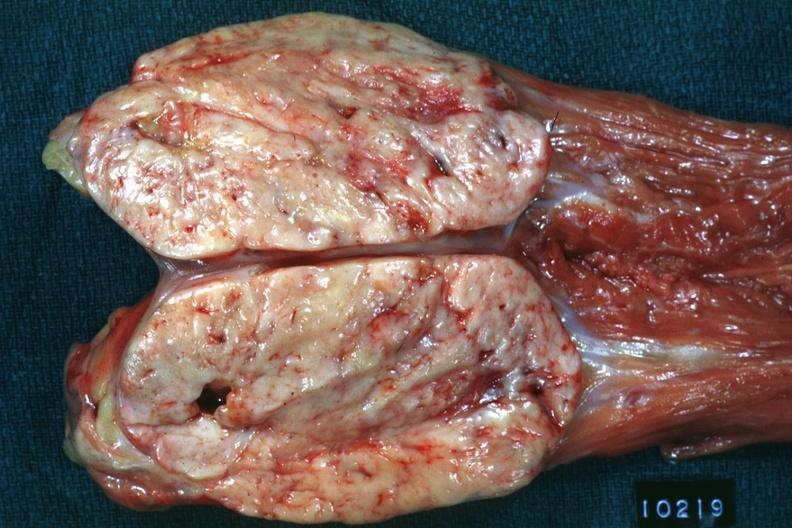s retroperitoneal leiomyosarcoma present?
Answer the question using a single word or phrase. Yes 